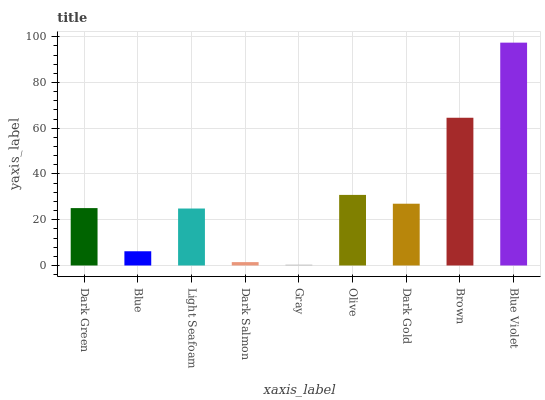Is Gray the minimum?
Answer yes or no. Yes. Is Blue Violet the maximum?
Answer yes or no. Yes. Is Blue the minimum?
Answer yes or no. No. Is Blue the maximum?
Answer yes or no. No. Is Dark Green greater than Blue?
Answer yes or no. Yes. Is Blue less than Dark Green?
Answer yes or no. Yes. Is Blue greater than Dark Green?
Answer yes or no. No. Is Dark Green less than Blue?
Answer yes or no. No. Is Dark Green the high median?
Answer yes or no. Yes. Is Dark Green the low median?
Answer yes or no. Yes. Is Olive the high median?
Answer yes or no. No. Is Dark Salmon the low median?
Answer yes or no. No. 